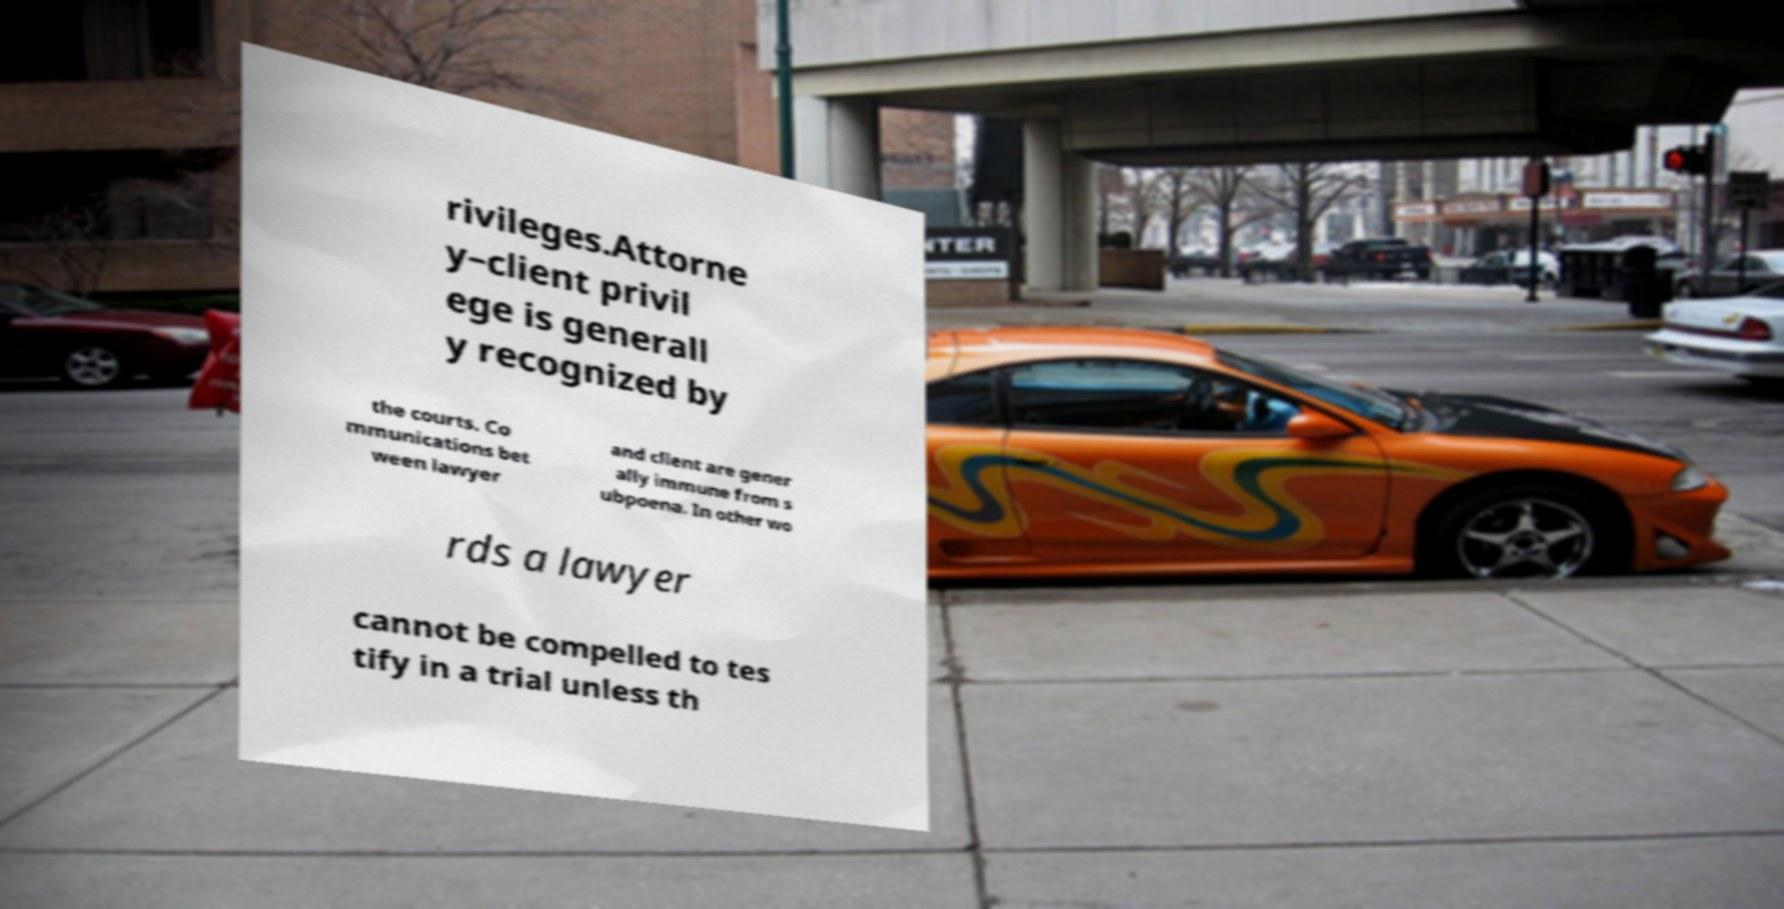Could you assist in decoding the text presented in this image and type it out clearly? rivileges.Attorne y–client privil ege is generall y recognized by the courts. Co mmunications bet ween lawyer and client are gener ally immune from s ubpoena. In other wo rds a lawyer cannot be compelled to tes tify in a trial unless th 